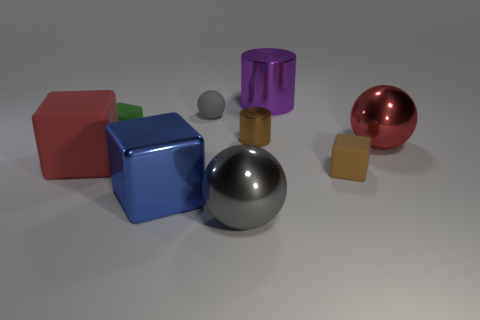Add 1 tiny gray matte balls. How many objects exist? 10 Subtract all spheres. How many objects are left? 6 Add 2 large shiny cylinders. How many large shiny cylinders are left? 3 Add 7 big red matte cylinders. How many big red matte cylinders exist? 7 Subtract 0 gray cubes. How many objects are left? 9 Subtract all blue things. Subtract all gray rubber balls. How many objects are left? 7 